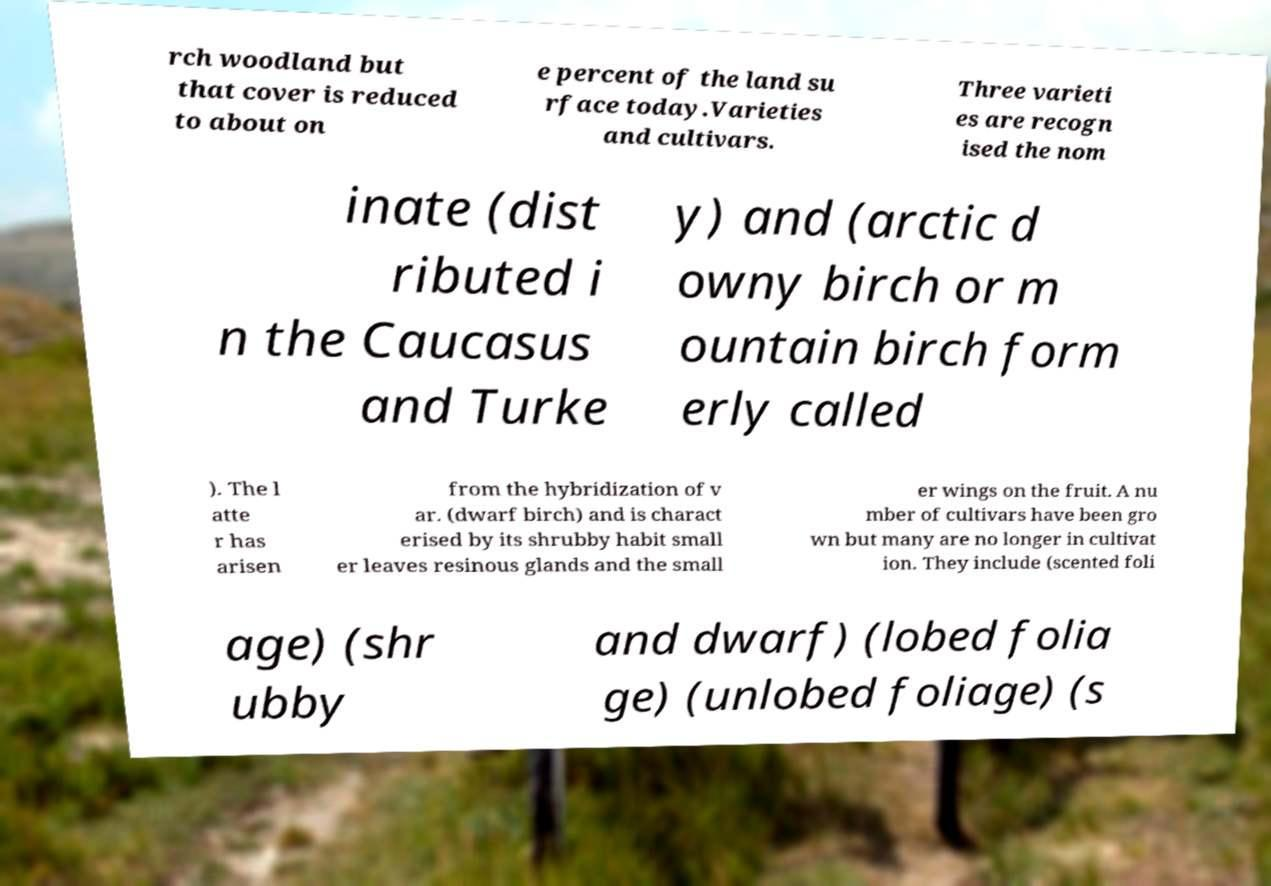Can you read and provide the text displayed in the image?This photo seems to have some interesting text. Can you extract and type it out for me? rch woodland but that cover is reduced to about on e percent of the land su rface today.Varieties and cultivars. Three varieti es are recogn ised the nom inate (dist ributed i n the Caucasus and Turke y) and (arctic d owny birch or m ountain birch form erly called ). The l atte r has arisen from the hybridization of v ar. (dwarf birch) and is charact erised by its shrubby habit small er leaves resinous glands and the small er wings on the fruit. A nu mber of cultivars have been gro wn but many are no longer in cultivat ion. They include (scented foli age) (shr ubby and dwarf) (lobed folia ge) (unlobed foliage) (s 